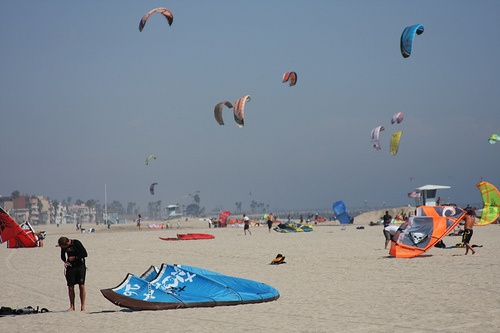Describe the objects in this image and their specific colors. I can see kite in gray and darkgray tones, kite in gray, teal, lightblue, and maroon tones, people in gray, black, maroon, and brown tones, kite in gray and olive tones, and kite in gray, teal, blue, black, and darkblue tones in this image. 